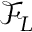<formula> <loc_0><loc_0><loc_500><loc_500>\mathcal { F } _ { L }</formula> 